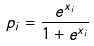<formula> <loc_0><loc_0><loc_500><loc_500>p _ { i } = \frac { e ^ { x _ { i } } } { 1 + e ^ { x _ { i } } }</formula> 